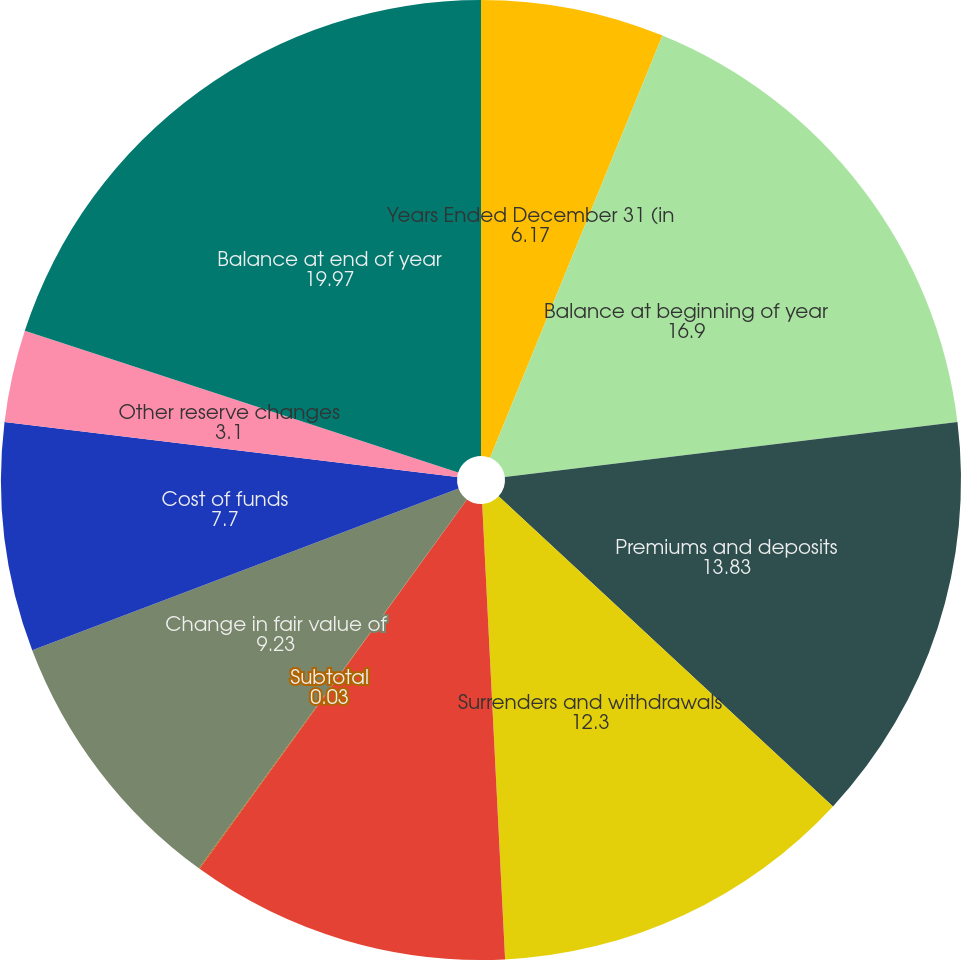Convert chart to OTSL. <chart><loc_0><loc_0><loc_500><loc_500><pie_chart><fcel>Years Ended December 31 (in<fcel>Balance at beginning of year<fcel>Premiums and deposits<fcel>Surrenders and withdrawals<fcel>Death and other contract<fcel>Subtotal<fcel>Change in fair value of<fcel>Cost of funds<fcel>Other reserve changes<fcel>Balance at end of year<nl><fcel>6.17%<fcel>16.9%<fcel>13.83%<fcel>12.3%<fcel>10.77%<fcel>0.03%<fcel>9.23%<fcel>7.7%<fcel>3.1%<fcel>19.97%<nl></chart> 